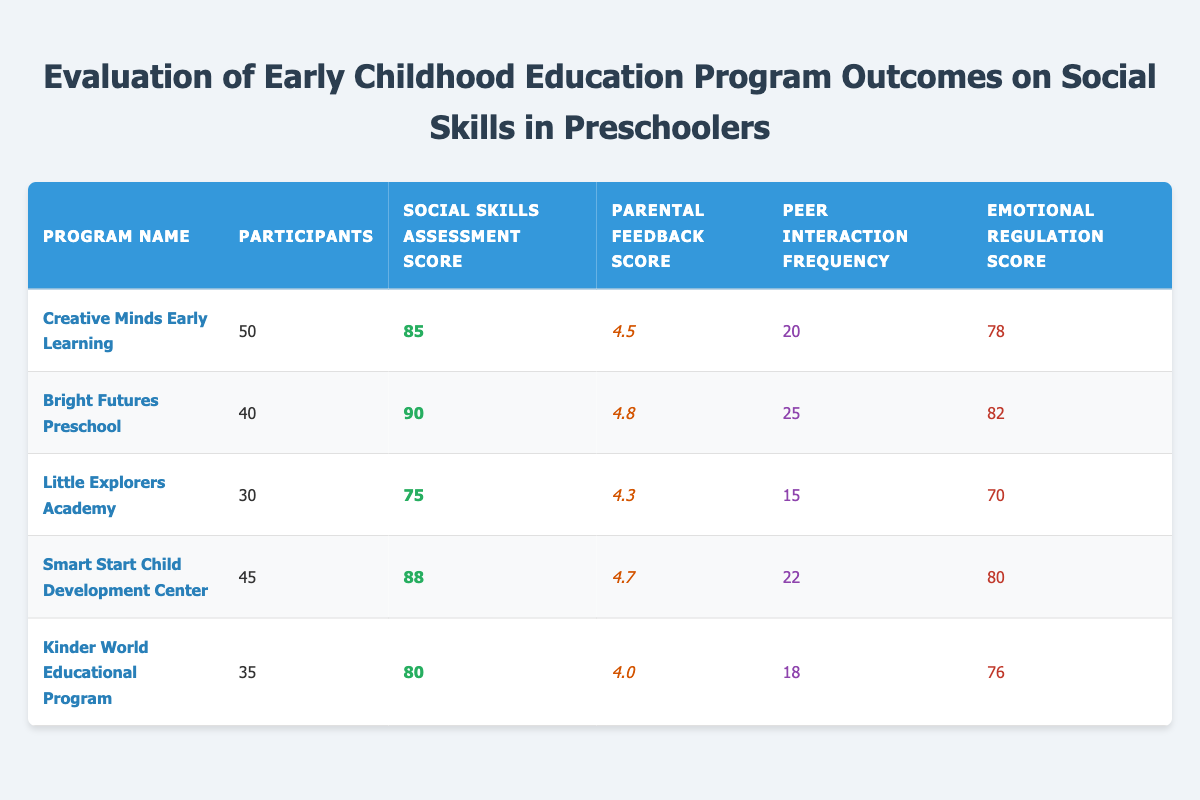What is the highest Social Skills Assessment Score among the programs? The Social Skills Assessment Scores for the programs are as follows: Creative Minds Early Learning (85), Bright Futures Preschool (90), Little Explorers Academy (75), Smart Start Child Development Center (88), and Kinder World Educational Program (80). The highest score is 90 from Bright Futures Preschool.
Answer: 90 Which program had the lowest Parental Feedback Score? The Parental Feedback Scores for the programs are: Creative Minds Early Learning (4.5), Bright Futures Preschool (4.8), Little Explorers Academy (4.3), Smart Start Child Development Center (4.7), and Kinder World Educational Program (4.0). The lowest score is 4.0 from Kinder World Educational Program.
Answer: 4.0 What is the average Peer Interaction Frequency of all programs? The Peer Interaction Frequencies are: 20, 25, 15, 22, and 18. First, sum these values: 20 + 25 + 15 + 22 + 18 = 100. Then, divide by the number of programs (5): 100 / 5 = 20.
Answer: 20 Is the Emotional Regulation Score in Creative Minds Early Learning higher than that in Little Explorers Academy? The Emotional Regulation Scores are: Creative Minds Early Learning (78) and Little Explorers Academy (70). Since 78 is greater than 70, the statement is true.
Answer: Yes How many programs had Social Skills Assessment Scores above 80? The scores above 80 are from the following programs: Bright Futures Preschool (90), Smart Start Child Development Center (88), and Creative Minds Early Learning (85). That totals to three programs.
Answer: 3 What is the difference in Peer Interaction Frequency between the program with the highest score and the program with the lowest score? The highest Peer Interaction Frequency is 25 from Bright Futures Preschool, and the lowest is 15 from Little Explorers Academy. The difference is calculated as follows: 25 - 15 = 10.
Answer: 10 Did more participants attend the Little Explorers Academy than the Kinder World Educational Program? Little Explorers Academy has 30 participants, while Kinder World Educational Program has 35 participants. Since 30 is less than 35, the statement is false.
Answer: No Which program had the highest sum of Social Skills Assessment Score and Emotional Regulation Score? The sums for each program are as follows: Creative Minds Early Learning (85 + 78 = 163), Bright Futures Preschool (90 + 82 = 172), Little Explorers Academy (75 + 70 = 145), Smart Start Child Development Center (88 + 80 = 168), and Kinder World Educational Program (80 + 76 = 156). The highest sum is 172 from Bright Futures Preschool.
Answer: Bright Futures Preschool 